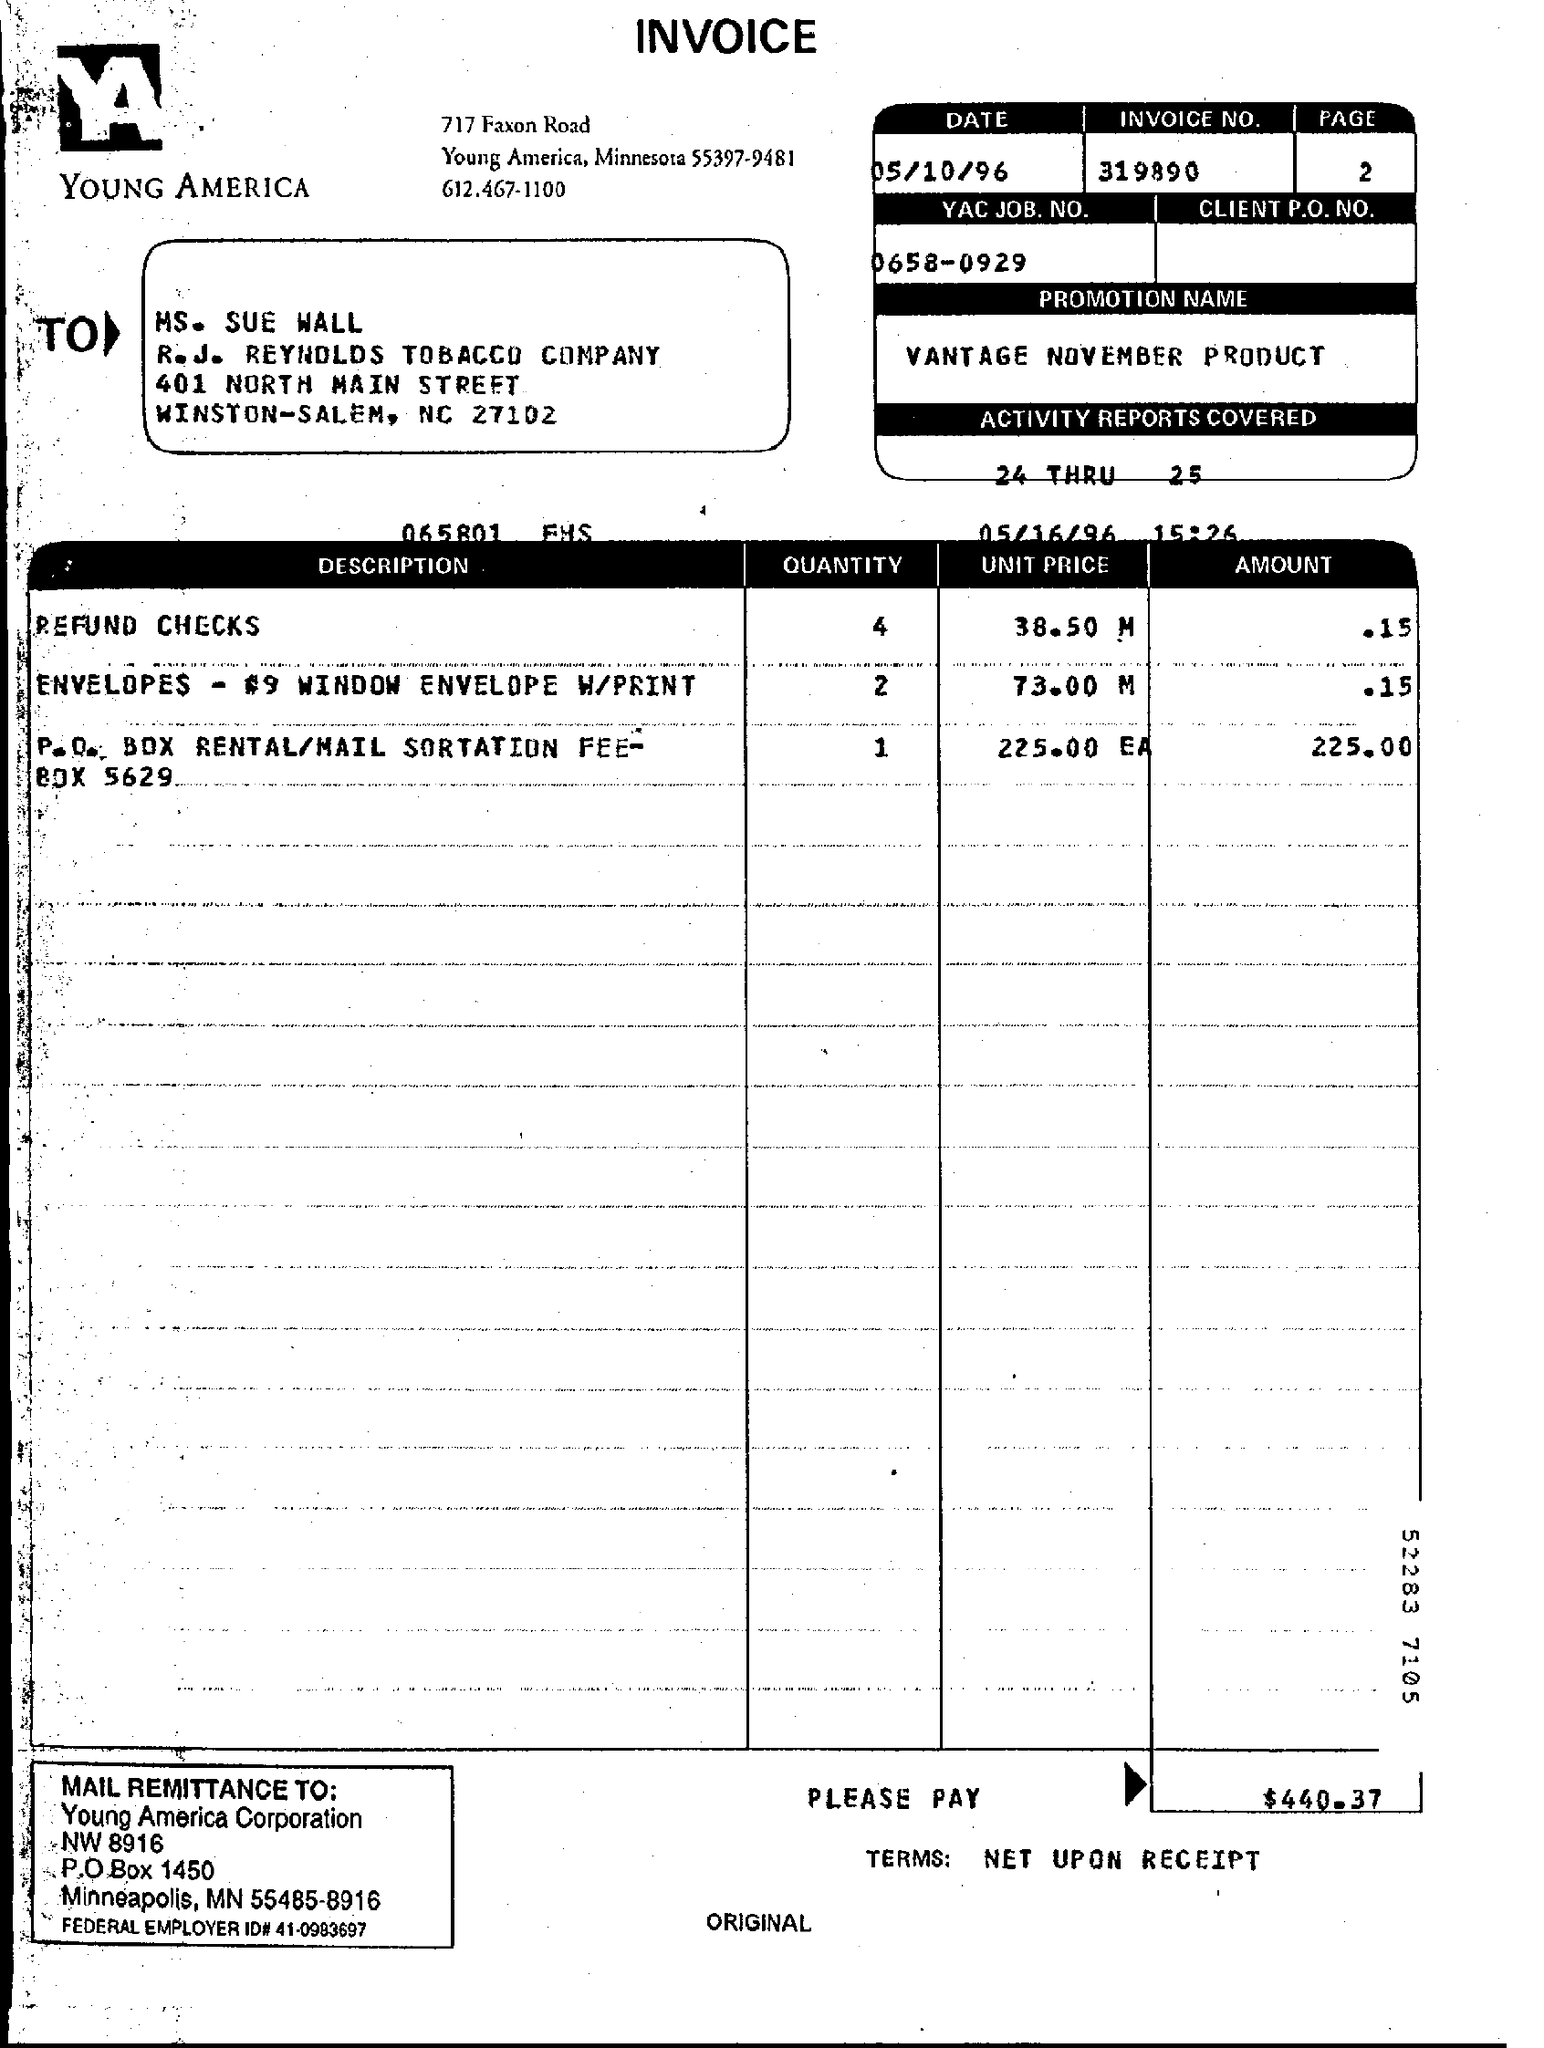What is the date mentioned ?
Offer a very short reply. 05/10/96. What is the invoice no ?
Your response must be concise. 319890. What is the page no mentioned?
Make the answer very short. 2. To whom this letter is sent ?
Provide a short and direct response. Ms. SUE WALL. What is the promotion name ?
Your response must be concise. VANTAGE NOVEMBER PRODUCT. What is yac job. no
Ensure brevity in your answer.  0658-0929. What is the federal employer id# ?
Make the answer very short. 41-0983697. What is the p.o box of young america corporation ?
Your answer should be compact. 1450. What is the quantity of refund checks ?
Provide a succinct answer. 4. What is the total amount that has to be paid ?
Provide a succinct answer. $440.37. 